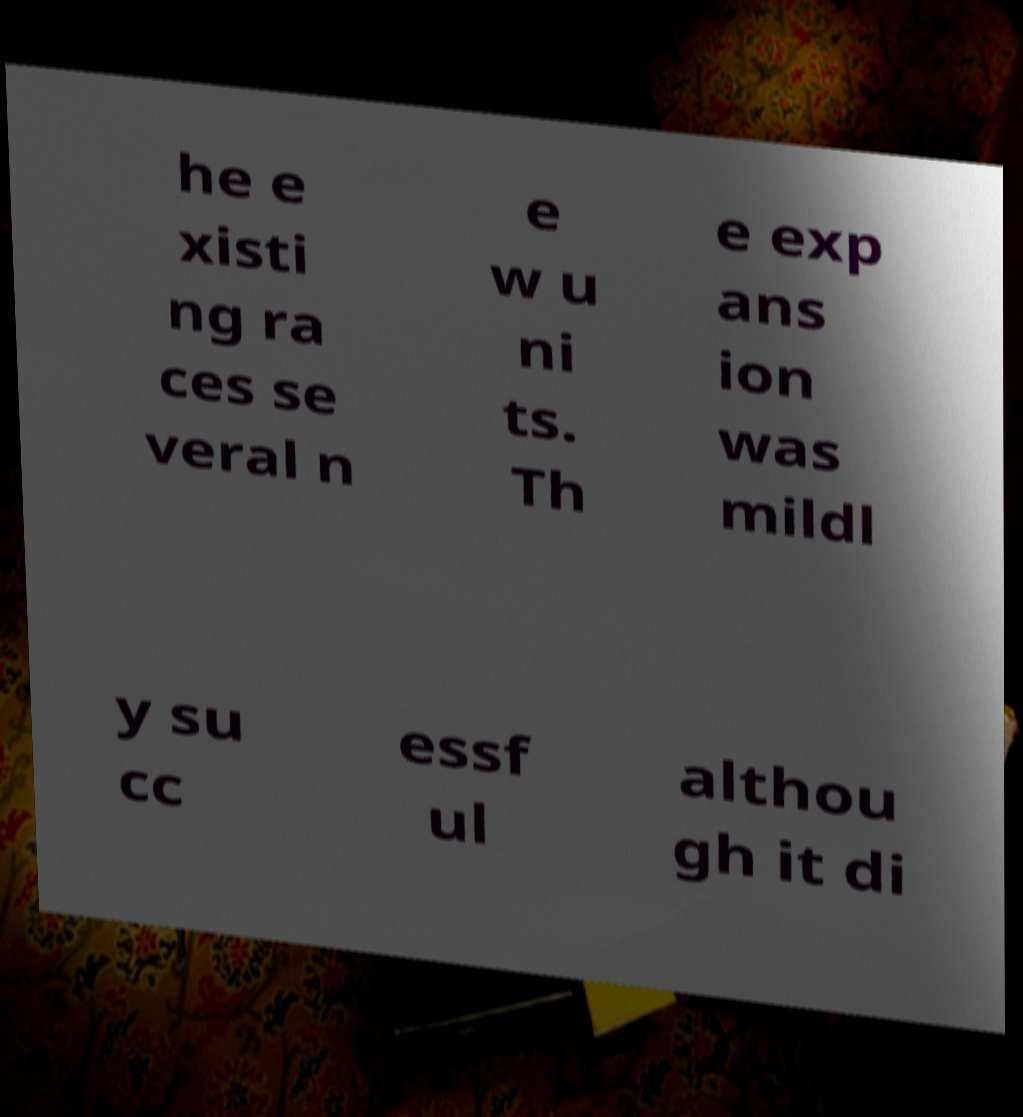I need the written content from this picture converted into text. Can you do that? he e xisti ng ra ces se veral n e w u ni ts. Th e exp ans ion was mildl y su cc essf ul althou gh it di 